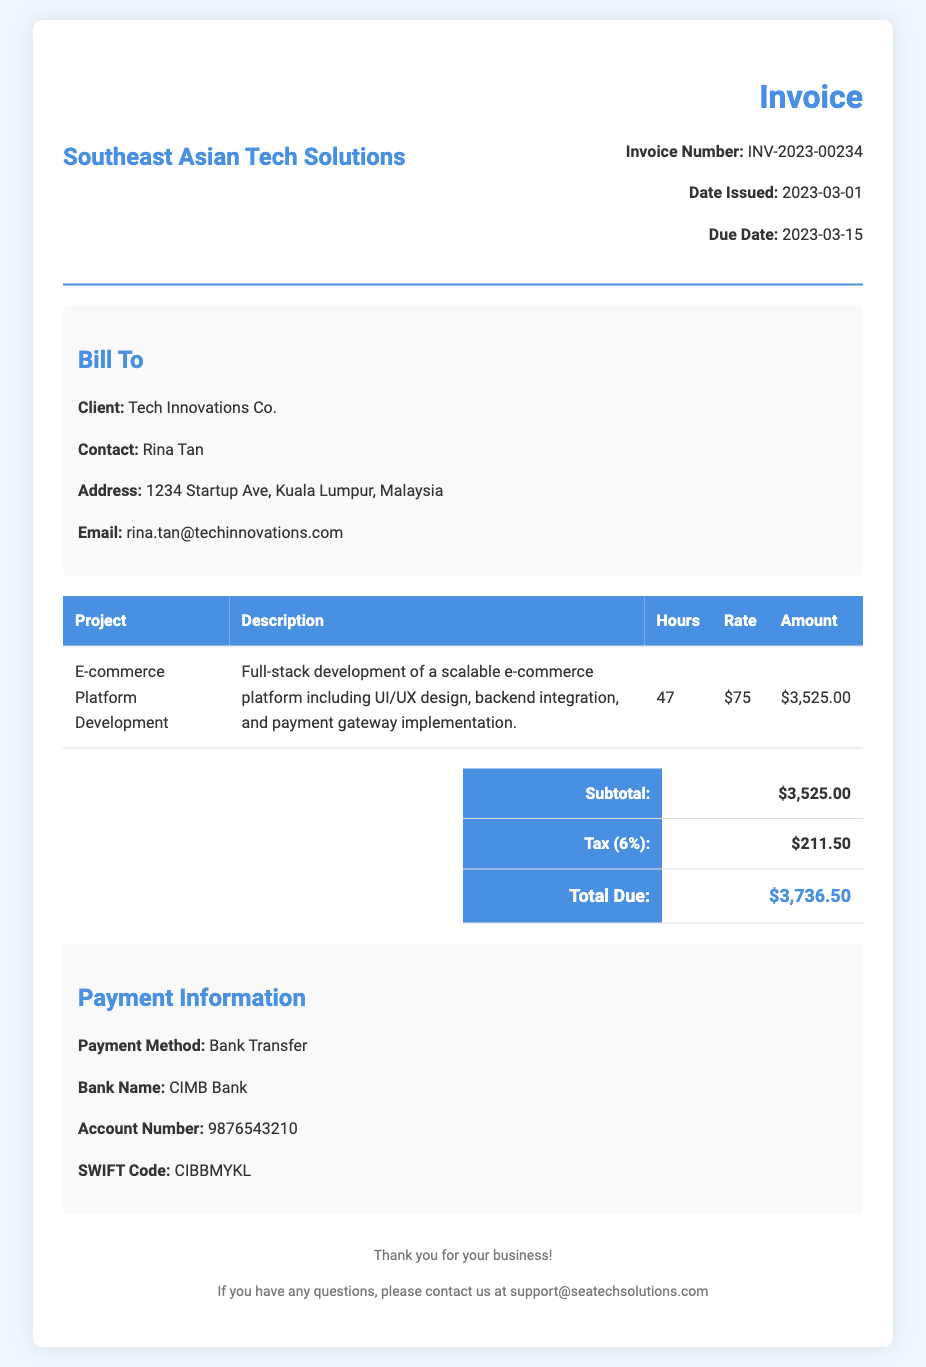What is the invoice number? The invoice number is listed prominently in the document as part of the header section.
Answer: INV-2023-00234 What is the date issued? The date issued is specified right under the invoice number in the details provided.
Answer: 2023-03-01 Who is the client? The client's name is given in the "Bill To" section of the document.
Answer: Tech Innovations Co How many hours were logged for the project? The hours worked for the project are detailed in the table of services rendered.
Answer: 47 What is the total due amount? The total due is calculated in the summary section, based on the subtotal and tax values.
Answer: $3,736.50 What is the hourly rate for the development services? The hourly rate is listed in the project details of the invoice table.
Answer: $75 What payment method is mentioned? The payment method is indicated in the "Payment Information" section of the document.
Answer: Bank Transfer What is the tax percentage applied? The tax percentage is present in the summary table of the invoice.
Answer: 6% How many days are there until the due date from the date issued? The due date and the date issued provide a timeline calculation for the invoice.
Answer: 14 days What is the account number for payment? The account number is included in the payment information provided at the end of the document.
Answer: 9876543210 